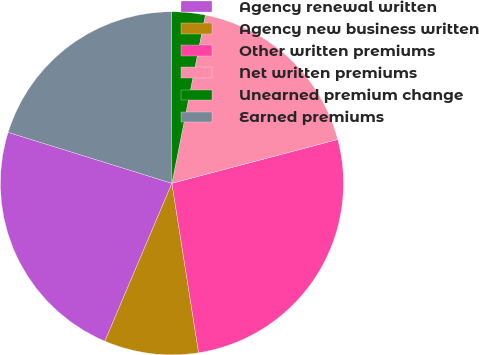<chart> <loc_0><loc_0><loc_500><loc_500><pie_chart><fcel>Agency renewal written<fcel>Agency new business written<fcel>Other written premiums<fcel>Net written premiums<fcel>Unearned premium change<fcel>Earned premiums<nl><fcel>23.41%<fcel>8.88%<fcel>26.63%<fcel>17.76%<fcel>3.15%<fcel>20.18%<nl></chart> 